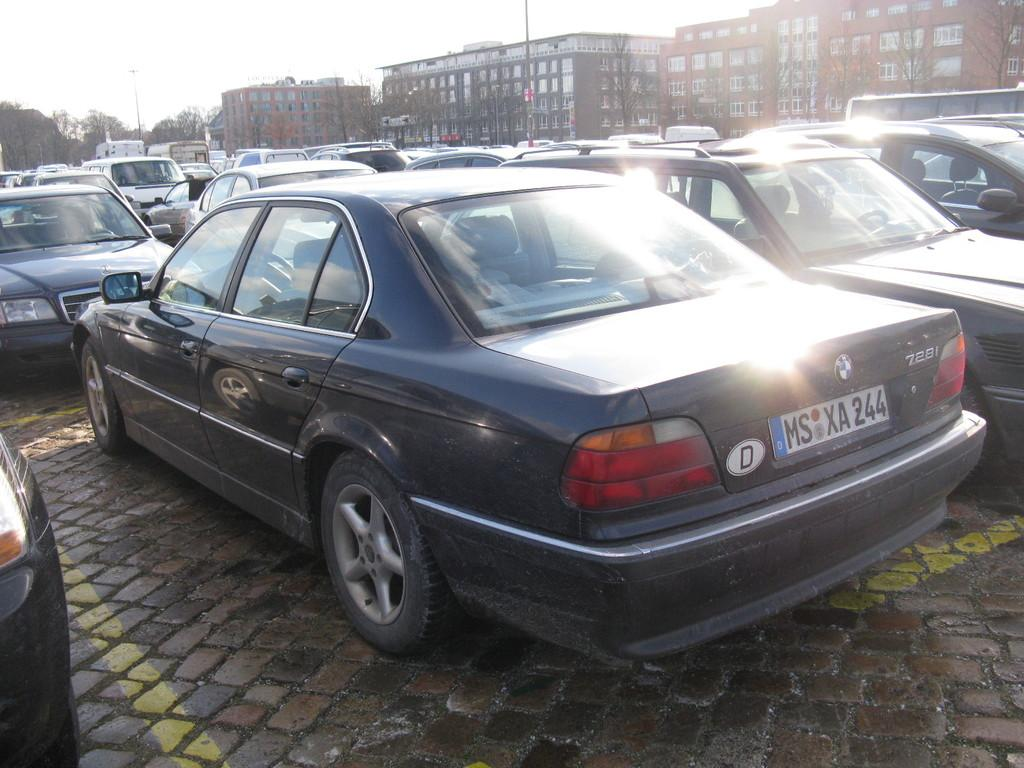What can be seen on the road in the image? There are vehicles on the road in the image. What type of structures are visible in the image? There are buildings with windows in the image. What type of vegetation is present in the image? There are trees in the image. What else can be seen in the image besides the vehicles, buildings, and trees? There are poles in the image. What is visible in the background of the image? The sky is visible in the background of the image. Can you tell me how many pieces of fruit are hanging from the poles in the image? There is no fruit present in the image; it features vehicles, buildings, trees, and poles. What type of rate is being discussed in the image? There is no discussion of a rate in the image; it focuses on vehicles, buildings, trees, and poles. 